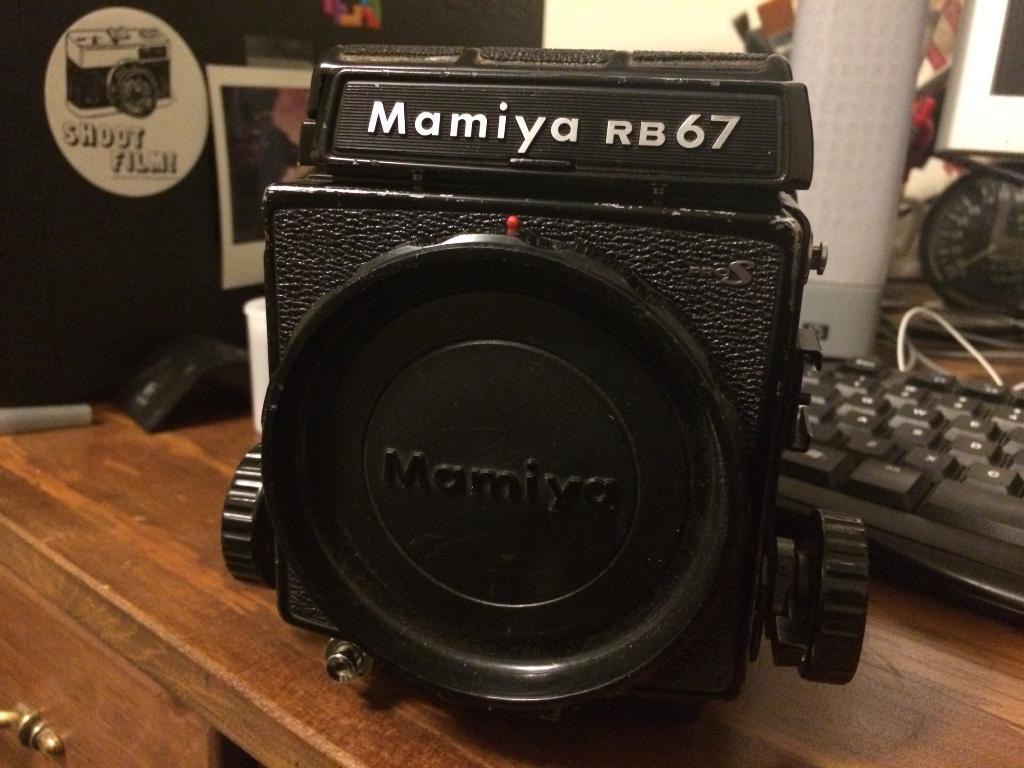What camera is that?
Your answer should be very brief. Mamiya rb67. 